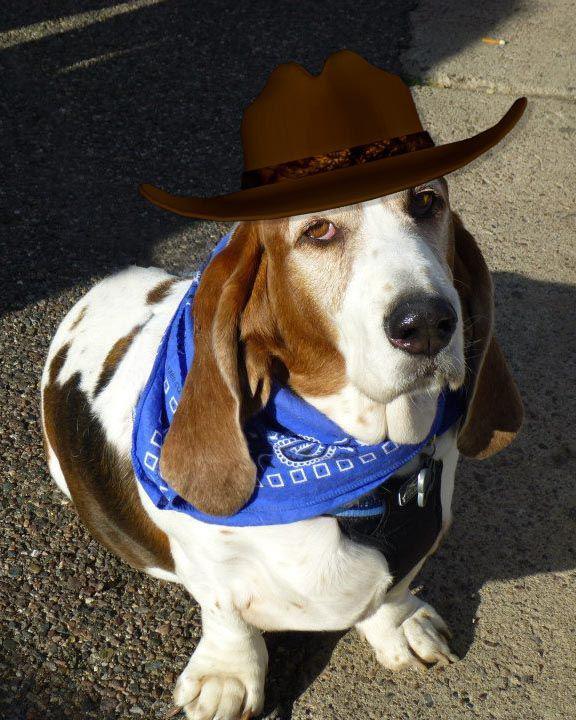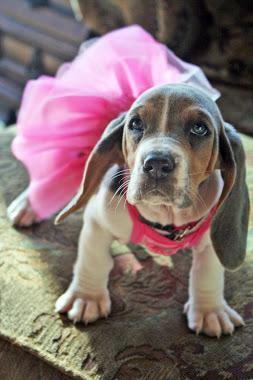The first image is the image on the left, the second image is the image on the right. Examine the images to the left and right. Is the description "there is only one dog in the image on the left side and it is not wearing bunny ears." accurate? Answer yes or no. Yes. The first image is the image on the left, the second image is the image on the right. For the images displayed, is the sentence "A real basset hound is wearing rabbit hears." factually correct? Answer yes or no. No. 